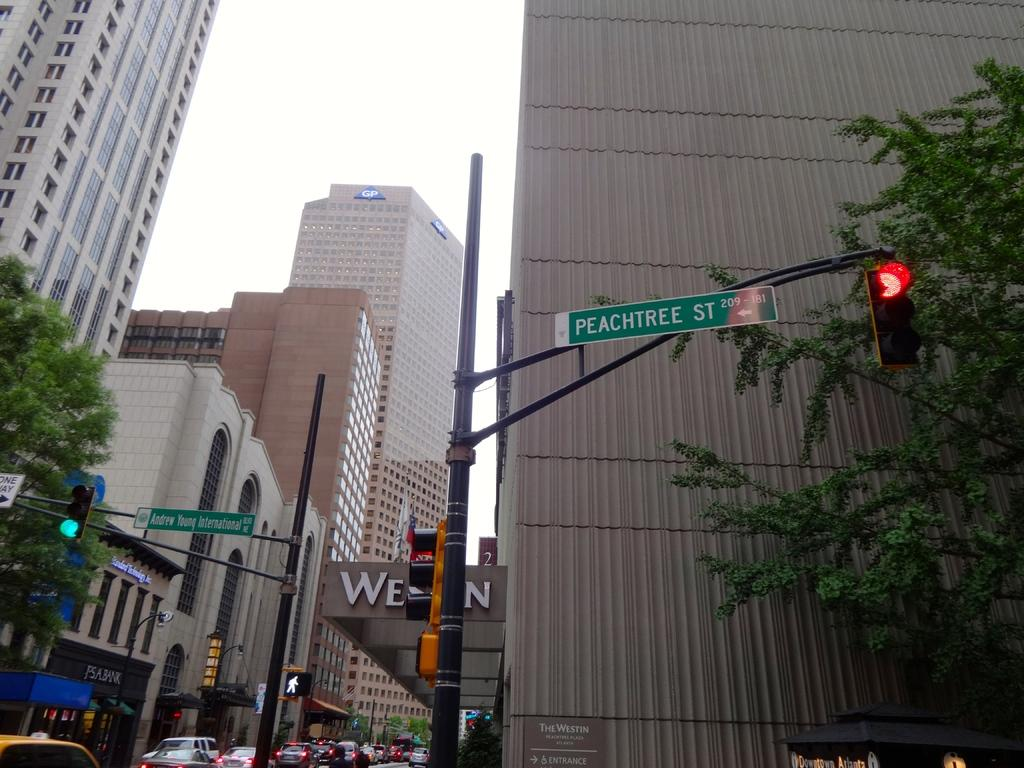<image>
Summarize the visual content of the image. a peachtree street sign next to a traffic light 